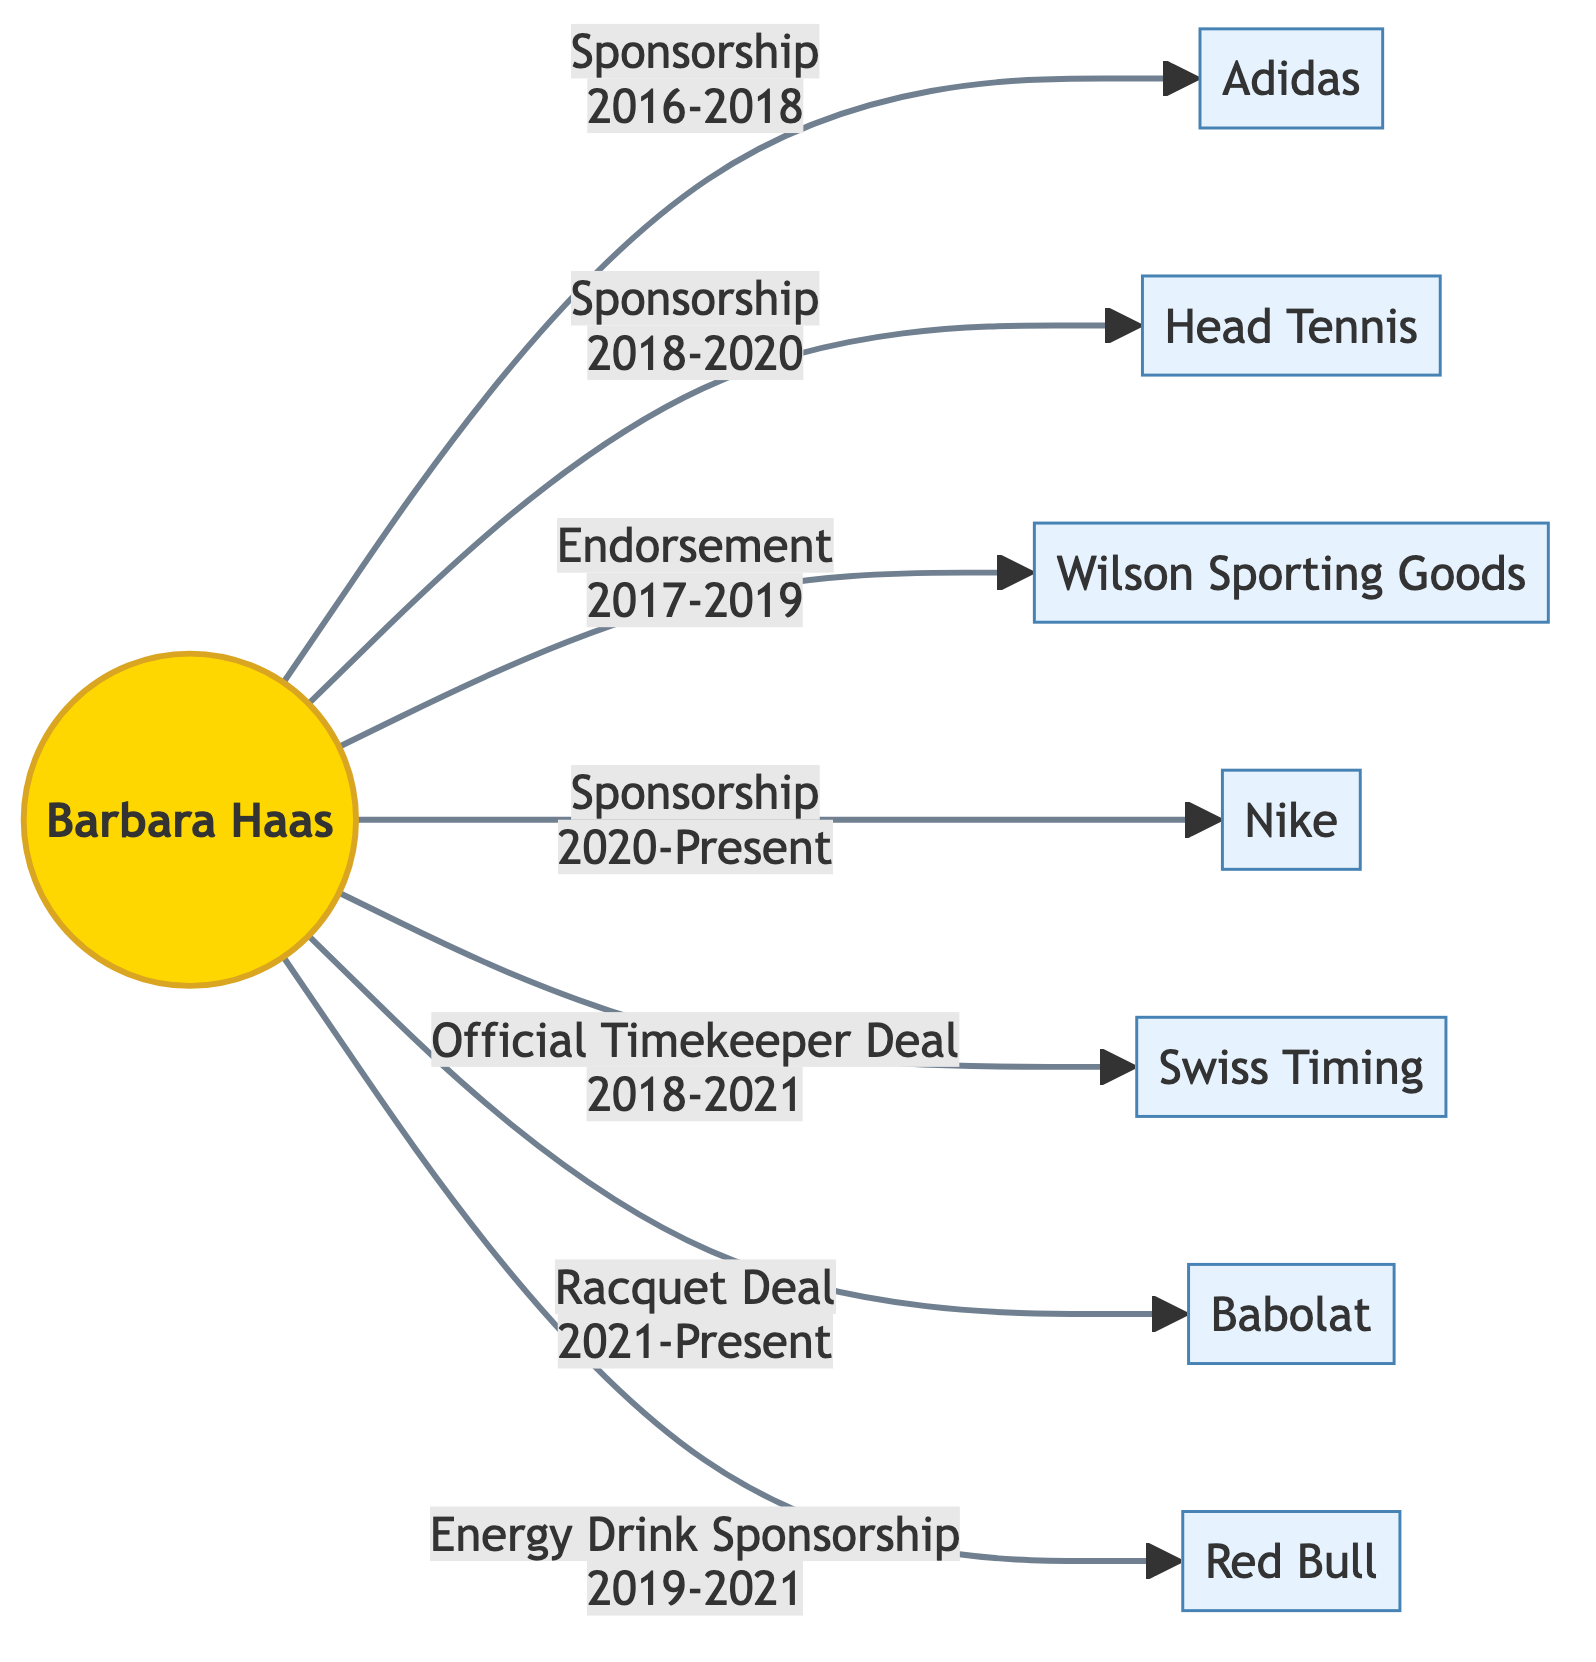What companies has Barbara Haas been sponsored by until 2021? To answer this, we can look at the edges leading from Barbara Haas to nodes representing sponsors. The companies include Adidas, Head Tennis, Wilson Sporting Goods, Nike, Swiss Timing, Babolat, and Red Bull. Therefore, we list the relevant companies that have sponsorship or endorsement deals with her until the end of 2021.
Answer: Adidas, Head Tennis, Wilson Sporting Goods, Nike, Swiss Timing, Babolat, Red Bull What type of deal did Barbara Haas have with Swiss Timing? The edge connecting Barbara Haas to Swiss Timing indicates the relationship is labeled "Official Timekeeper Deal." Thus, the type of deal is clearly stated in the diagram.
Answer: Official Timekeeper Deal How many total sponsorship deals does Barbara Haas have? By examining the edges, we can count the total number of sponsorship deals. Barbara Haas has three sponsorship deals (with Adidas, Head Tennis, and Nike) and one energy drink sponsorship (with Red Bull) that counts as a different type of sponsorship. Therefore, we count those up and get the total.
Answer: 4 What is the duration of Barbara Haas's deal with Babolat? The edge between Barbara Haas and Babolat shows that the label for this deal is "Racquet Deal" and is effective from 2021 to the present. Hence, to answer this, we refer to the specific timestamps mentioned.
Answer: 2021-Present Which company did Barbara Haas partner with for an energy drink sponsorship? From the diagram, we follow the edge labeled "Energy Drink Sponsorship" to identify the partner. The edge connects Barbara Haas to Red Bull, showing that this is the company she partnered with.
Answer: Red Bull How many companies had endorsement deals with Barbara Haas between 2017 and 2019? By looking at the edges labeled as "Endorsement" and their associated timestamps, we can check which endorsements fall within the specified time frame. There is only one endorsement deal during this period with Wilson Sporting Goods.
Answer: 1 Which sponsor did Barbara Haas have a deal with for the longest duration? To determine which sponsorship lasted the longest, we compare the timestamps of the edges. The sponsorship with Nike (2020-Present) and the "Sponsorship" with Adidas (2016-2018) can be disappointing as they don't overlap in duration. Our focus will be on longer active contracts that are indefinite and ongoing. Ultimately, "Sponsorship 2020-Present" with Nike suggests an indefinite duration.
Answer: Nike 